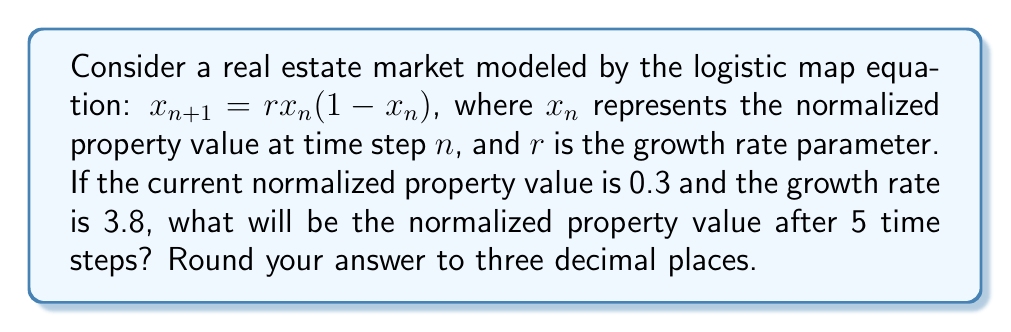Give your solution to this math problem. To solve this problem, we need to iterate the logistic map equation for 5 time steps:

1) Initial conditions:
   $x_0 = 0.3$ (initial normalized property value)
   $r = 3.8$ (growth rate parameter)

2) Iterate the equation for 5 time steps:

   Step 1: $x_1 = 3.8 * 0.3 * (1 - 0.3) = 0.798$
   
   Step 2: $x_2 = 3.8 * 0.798 * (1 - 0.798) = 0.613$
   
   Step 3: $x_3 = 3.8 * 0.613 * (1 - 0.613) = 0.903$
   
   Step 4: $x_4 = 3.8 * 0.903 * (1 - 0.903) = 0.332$
   
   Step 5: $x_5 = 3.8 * 0.332 * (1 - 0.332) = 0.841$

3) The final value after 5 time steps is 0.841.

4) Rounding to three decimal places: 0.841

This demonstrates how small changes in initial conditions can lead to significant and unpredictable changes over time, which is a key principle of chaos theory applied to real estate market fluctuations.
Answer: 0.841 